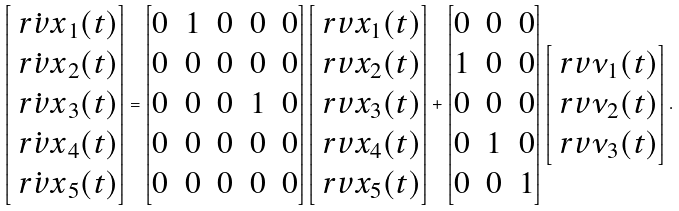Convert formula to latex. <formula><loc_0><loc_0><loc_500><loc_500>\begin{bmatrix} \dot { \ r v { x } } _ { 1 } ( t ) \\ \dot { \ r v { x } } _ { 2 } ( t ) \\ \dot { \ r v { x } } _ { 3 } ( t ) \\ \dot { \ r v { x } } _ { 4 } ( t ) \\ \dot { \ r v { x } } _ { 5 } ( t ) \end{bmatrix} = \begin{bmatrix} 0 & 1 & 0 & 0 & 0 \\ 0 & 0 & 0 & 0 & 0 \\ 0 & 0 & 0 & 1 & 0 \\ 0 & 0 & 0 & 0 & 0 \\ 0 & 0 & 0 & 0 & 0 \end{bmatrix} \begin{bmatrix} \ r v { x } _ { 1 } ( t ) \\ \ r v { x } _ { 2 } ( t ) \\ \ r v { x } _ { 3 } ( t ) \\ \ r v { x } _ { 4 } ( t ) \\ \ r v { x } _ { 5 } ( t ) \end{bmatrix} + \begin{bmatrix} 0 & 0 & 0 \\ 1 & 0 & 0 \\ 0 & 0 & 0 \\ 0 & 1 & 0 \\ 0 & 0 & 1 \end{bmatrix} \begin{bmatrix} \ r v { \nu } _ { 1 } ( t ) \\ \ r v { \nu } _ { 2 } ( t ) \\ \ r v { \nu } _ { 3 } ( t ) \end{bmatrix} .</formula> 